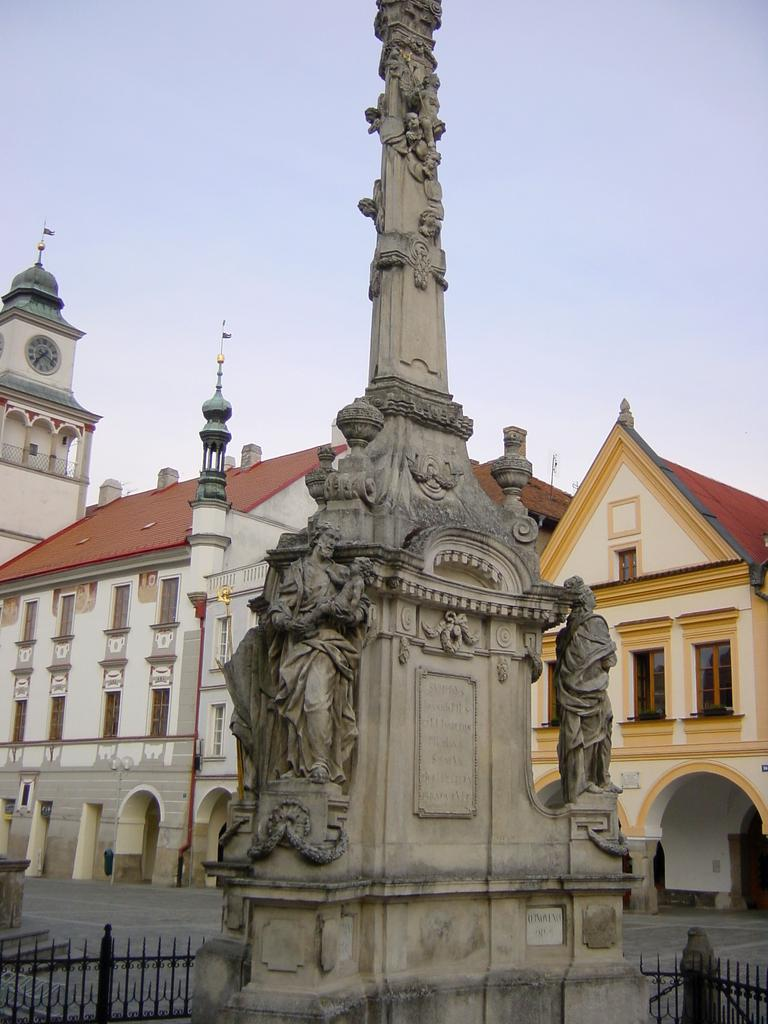What is the main subject of the image? There is a sculpture in the image. How is the sculpture protected or enclosed? The sculpture is surrounded by fencing. What can be seen in the background of the image? There are houses in the background of the image. Can you describe one specific detail about one of the houses? One of the houses has a clock on top. What is the weather like in the image? The sky is cloudy in the image. What process is being used to sort the statements in the image? There are no statements or sorting processes present in the image; it features a sculpture surrounded by fencing, houses in the background, and a cloudy sky. 